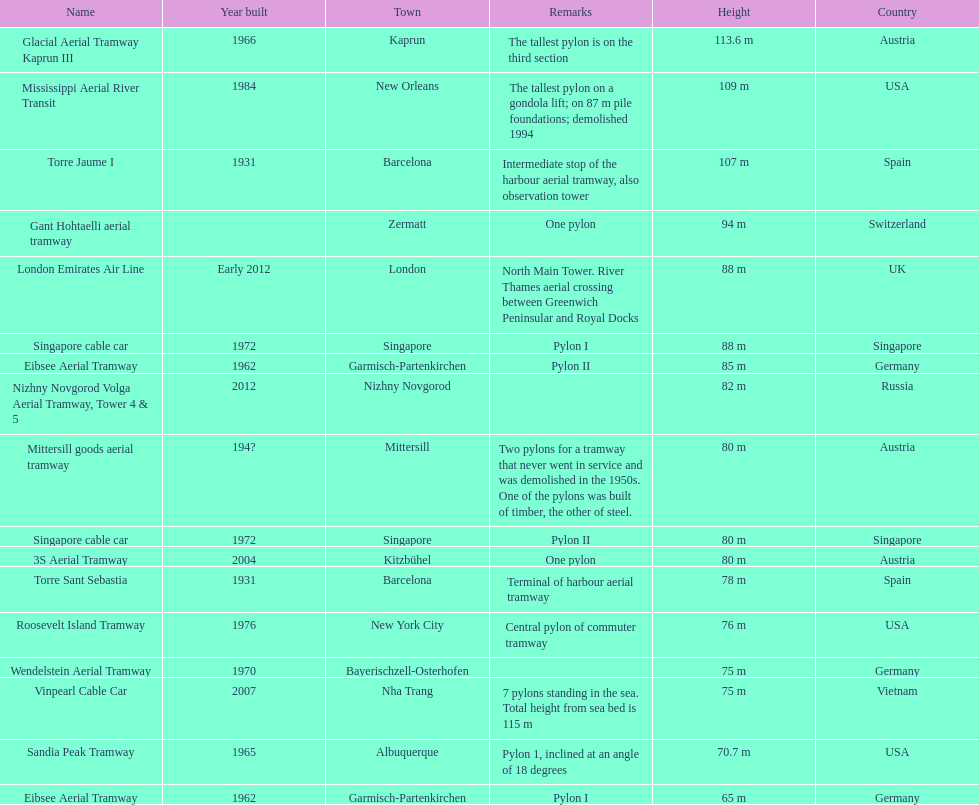How many pylons are in austria? 3. 